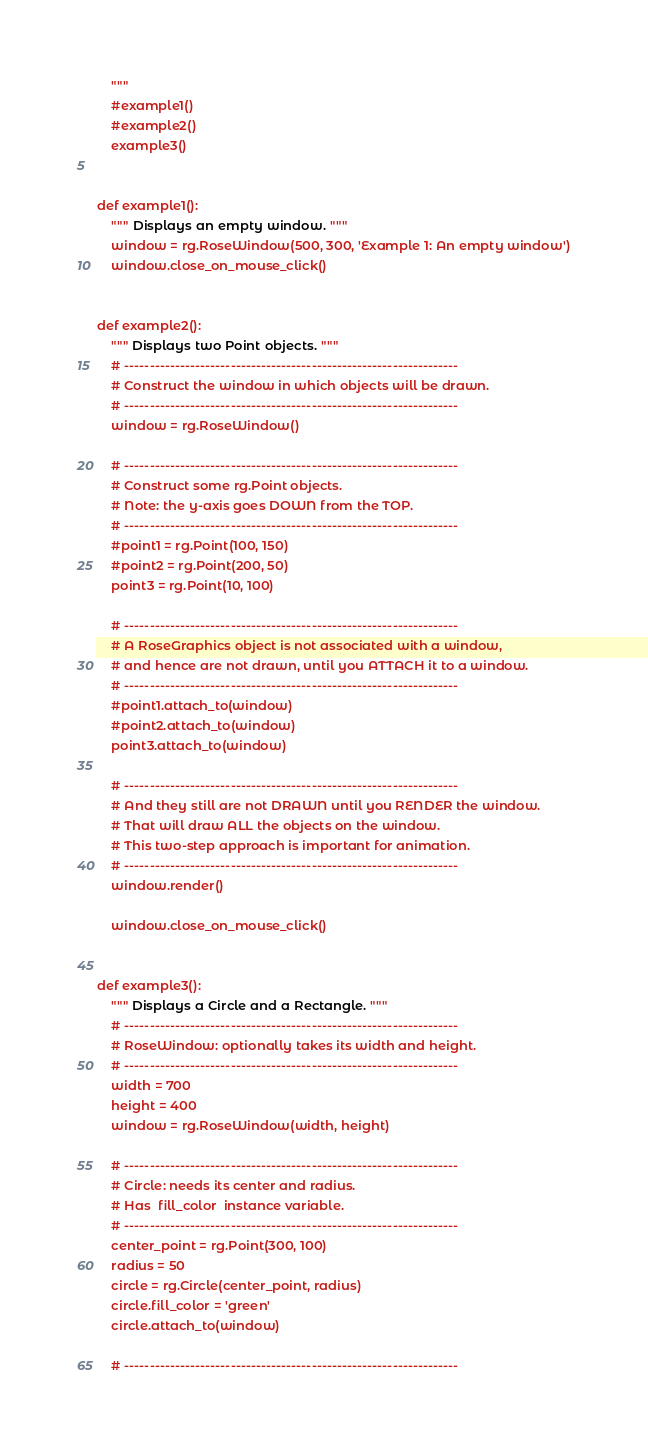Convert code to text. <code><loc_0><loc_0><loc_500><loc_500><_Python_>    """
    #example1()
    #example2()
    example3()


def example1():
    """ Displays an empty window. """
    window = rg.RoseWindow(500, 300, 'Example 1: An empty window')
    window.close_on_mouse_click()


def example2():
    """ Displays two Point objects. """
    # ------------------------------------------------------------------
    # Construct the window in which objects will be drawn.
    # ------------------------------------------------------------------
    window = rg.RoseWindow()

    # ------------------------------------------------------------------
    # Construct some rg.Point objects.
    # Note: the y-axis goes DOWN from the TOP.
    # ------------------------------------------------------------------
    #point1 = rg.Point(100, 150)
    #point2 = rg.Point(200, 50)
    point3 = rg.Point(10, 100)

    # ------------------------------------------------------------------
    # A RoseGraphics object is not associated with a window,
    # and hence are not drawn, until you ATTACH it to a window.
    # ------------------------------------------------------------------
    #point1.attach_to(window)
    #point2.attach_to(window)
    point3.attach_to(window)

    # ------------------------------------------------------------------
    # And they still are not DRAWN until you RENDER the window.
    # That will draw ALL the objects on the window.
    # This two-step approach is important for animation.
    # ------------------------------------------------------------------
    window.render()

    window.close_on_mouse_click()


def example3():
    """ Displays a Circle and a Rectangle. """
    # ------------------------------------------------------------------
    # RoseWindow: optionally takes its width and height.
    # ------------------------------------------------------------------
    width = 700
    height = 400
    window = rg.RoseWindow(width, height)

    # ------------------------------------------------------------------
    # Circle: needs its center and radius.
    # Has  fill_color  instance variable.
    # ------------------------------------------------------------------
    center_point = rg.Point(300, 100)
    radius = 50
    circle = rg.Circle(center_point, radius)
    circle.fill_color = 'green'
    circle.attach_to(window)

    # ------------------------------------------------------------------</code> 